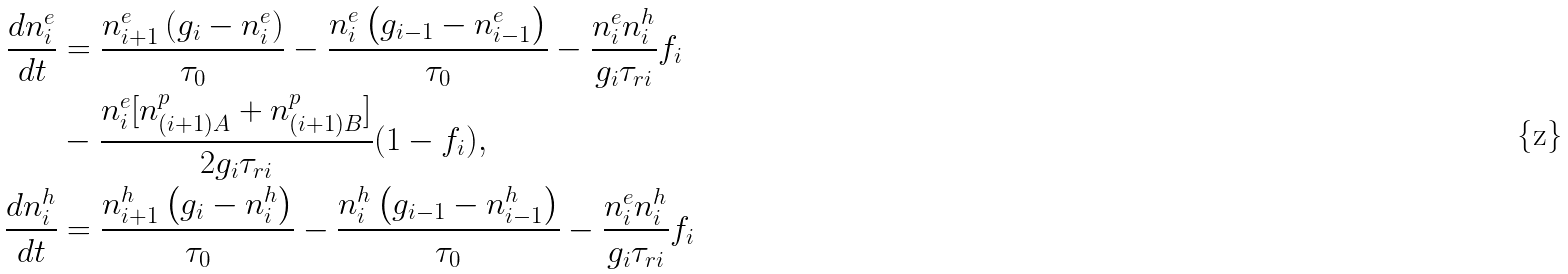Convert formula to latex. <formula><loc_0><loc_0><loc_500><loc_500>\frac { d n _ { i } ^ { e } } { d t } & = \frac { n _ { i + 1 } ^ { e } \left ( g _ { i } - n _ { i } ^ { e } \right ) } { \tau _ { 0 } } - \frac { n _ { i } ^ { e } \left ( g _ { i - 1 } - n _ { i - 1 } ^ { e } \right ) } { \tau _ { 0 } } - \frac { n _ { i } ^ { e } n _ { i } ^ { h } } { g _ { i } \tau _ { r i } } f _ { i } \\ & - \frac { n _ { i } ^ { e } [ n _ { ( i + 1 ) A } ^ { p } + n _ { ( i + 1 ) B } ^ { p } ] } { 2 g _ { i } \tau _ { r i } } ( 1 - f _ { i } ) , \\ \frac { d n _ { i } ^ { h } } { d t } & = \frac { n _ { i + 1 } ^ { h } \left ( g _ { i } - n _ { i } ^ { h } \right ) } { \tau _ { 0 } } - \frac { n _ { i } ^ { h } \left ( g _ { i - 1 } - n _ { i - 1 } ^ { h } \right ) } { \tau _ { 0 } } - \frac { n _ { i } ^ { e } n _ { i } ^ { h } } { g _ { i } \tau _ { r i } } f _ { i }</formula> 